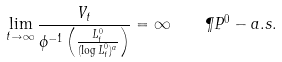Convert formula to latex. <formula><loc_0><loc_0><loc_500><loc_500>\lim _ { t \to \infty } \frac { V _ { t } } { \phi ^ { - 1 } \left ( \frac { L ^ { 0 } _ { t } } { ( \log L ^ { 0 } _ { t } ) ^ { a } } \right ) } = \infty \quad \P P ^ { 0 } - a . s .</formula> 